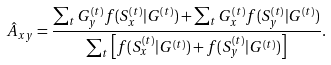<formula> <loc_0><loc_0><loc_500><loc_500>\hat { A } _ { x y } = \frac { \sum _ { t } G _ { y } ^ { ( t ) } f ( S _ { x } ^ { ( t ) } | G ^ { ( t ) } ) + \sum _ { t } G _ { x } ^ { ( t ) } f ( S _ { y } ^ { ( t ) } | G ^ { ( t ) } ) } { \sum _ { t } \left [ f ( S _ { x } ^ { ( t ) } | G ^ { ( t ) } ) + f ( S _ { y } ^ { ( t ) } | G ^ { ( t ) } ) \right ] } .</formula> 